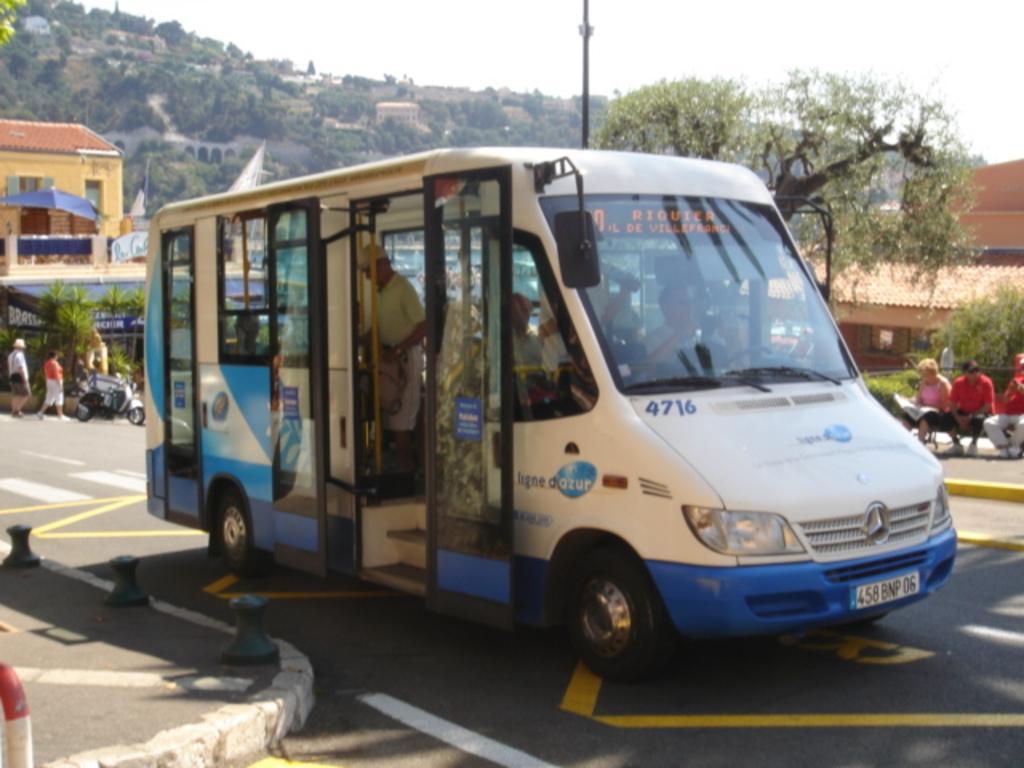How would you summarize this image in a sentence or two? In the image I can see a person in the vehicle and around there are some people, vehicles, trees, plants and houses. 